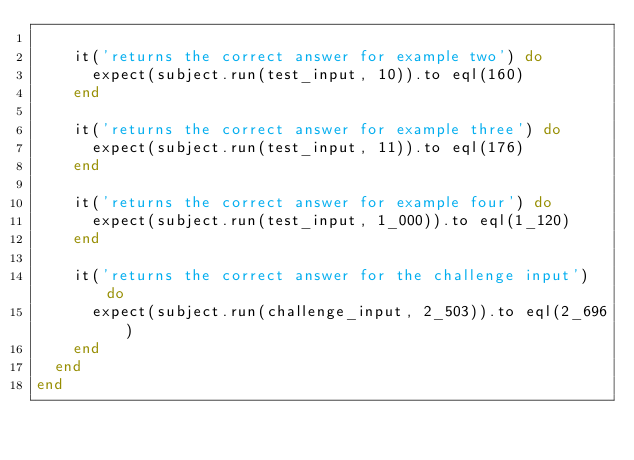Convert code to text. <code><loc_0><loc_0><loc_500><loc_500><_Ruby_>
    it('returns the correct answer for example two') do
      expect(subject.run(test_input, 10)).to eql(160)
    end

    it('returns the correct answer for example three') do
      expect(subject.run(test_input, 11)).to eql(176)
    end

    it('returns the correct answer for example four') do
      expect(subject.run(test_input, 1_000)).to eql(1_120)
    end

    it('returns the correct answer for the challenge input') do
      expect(subject.run(challenge_input, 2_503)).to eql(2_696)
    end
  end
end
</code> 